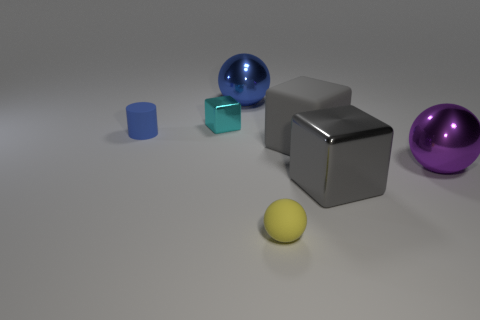Subtract all tiny cubes. How many cubes are left? 2 Add 1 red rubber balls. How many objects exist? 8 Subtract all blue balls. How many balls are left? 2 Subtract all cylinders. How many objects are left? 6 Subtract 2 spheres. How many spheres are left? 1 Subtract all green spheres. Subtract all brown cubes. How many spheres are left? 3 Subtract all yellow cylinders. How many green cubes are left? 0 Subtract all small yellow metal objects. Subtract all cyan objects. How many objects are left? 6 Add 3 small matte cylinders. How many small matte cylinders are left? 4 Add 1 big shiny balls. How many big shiny balls exist? 3 